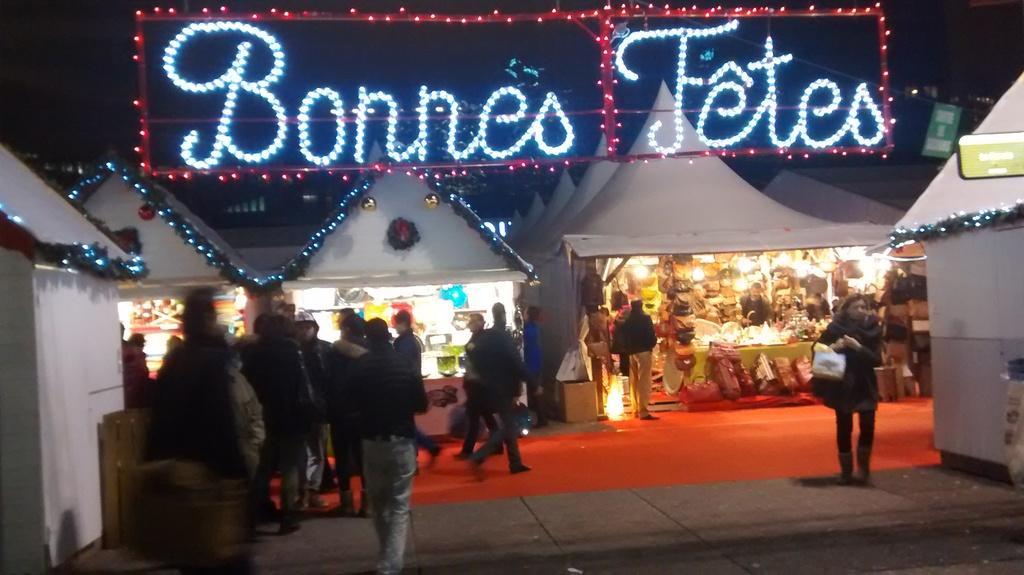How would you summarize this image in a sentence or two? In this image we can see the stalls with lights. And there are few people walking on the ground and a few people walking on the carpet. We can see the lights with text and dark background. 